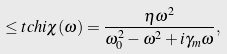<formula> <loc_0><loc_0><loc_500><loc_500>\leq t { c h i } \chi ( \omega ) = \frac { \eta \omega ^ { 2 } } { \omega _ { 0 } ^ { 2 } - \omega ^ { 2 } + i \gamma _ { m } \omega } ,</formula> 